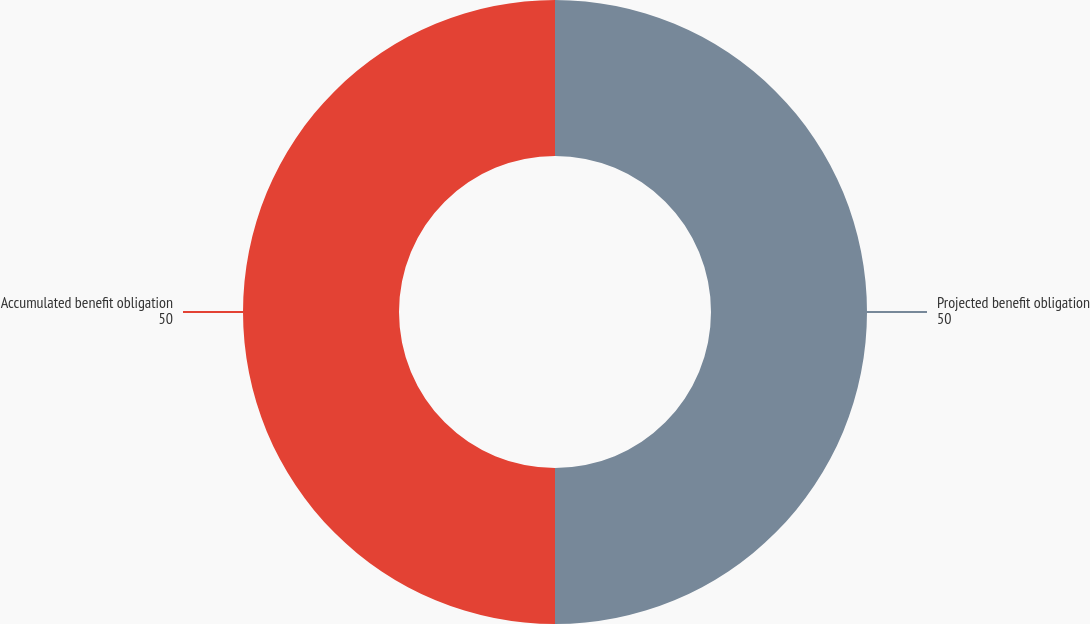Convert chart to OTSL. <chart><loc_0><loc_0><loc_500><loc_500><pie_chart><fcel>Projected benefit obligation<fcel>Accumulated benefit obligation<nl><fcel>50.0%<fcel>50.0%<nl></chart> 